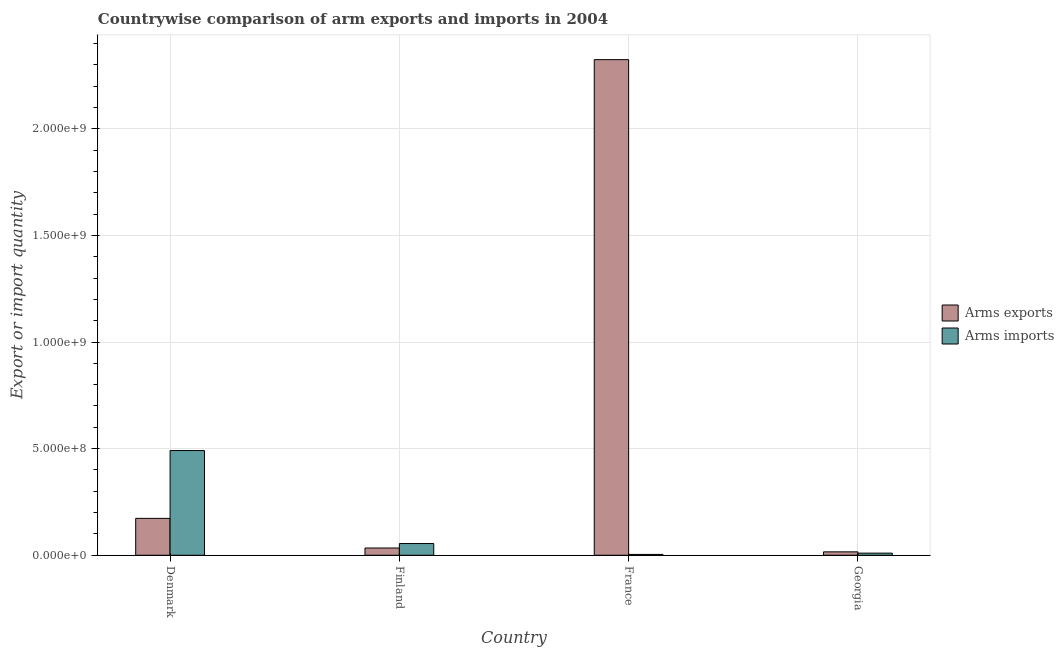Are the number of bars per tick equal to the number of legend labels?
Give a very brief answer. Yes. How many bars are there on the 3rd tick from the left?
Provide a succinct answer. 2. How many bars are there on the 3rd tick from the right?
Keep it short and to the point. 2. What is the label of the 2nd group of bars from the left?
Your answer should be compact. Finland. In how many cases, is the number of bars for a given country not equal to the number of legend labels?
Give a very brief answer. 0. What is the arms exports in France?
Give a very brief answer. 2.32e+09. Across all countries, what is the maximum arms imports?
Provide a short and direct response. 4.91e+08. Across all countries, what is the minimum arms imports?
Your answer should be compact. 4.00e+06. In which country was the arms exports minimum?
Offer a very short reply. Georgia. What is the total arms imports in the graph?
Offer a terse response. 5.60e+08. What is the difference between the arms imports in Finland and that in Georgia?
Offer a terse response. 4.50e+07. What is the difference between the arms exports in Denmark and the arms imports in Finland?
Give a very brief answer. 1.18e+08. What is the average arms exports per country?
Offer a terse response. 6.37e+08. What is the difference between the arms exports and arms imports in Finland?
Provide a succinct answer. -2.10e+07. What is the ratio of the arms exports in Denmark to that in Georgia?
Keep it short and to the point. 10.81. Is the arms exports in Finland less than that in France?
Ensure brevity in your answer.  Yes. Is the difference between the arms exports in Denmark and Finland greater than the difference between the arms imports in Denmark and Finland?
Your answer should be very brief. No. What is the difference between the highest and the second highest arms exports?
Give a very brief answer. 2.15e+09. What is the difference between the highest and the lowest arms imports?
Your answer should be compact. 4.87e+08. What does the 1st bar from the left in Georgia represents?
Offer a terse response. Arms exports. What does the 2nd bar from the right in France represents?
Give a very brief answer. Arms exports. How many bars are there?
Provide a short and direct response. 8. Are all the bars in the graph horizontal?
Your answer should be compact. No. How many countries are there in the graph?
Keep it short and to the point. 4. What is the difference between two consecutive major ticks on the Y-axis?
Keep it short and to the point. 5.00e+08. Are the values on the major ticks of Y-axis written in scientific E-notation?
Offer a very short reply. Yes. Does the graph contain any zero values?
Your response must be concise. No. How are the legend labels stacked?
Offer a very short reply. Vertical. What is the title of the graph?
Offer a very short reply. Countrywise comparison of arm exports and imports in 2004. Does "State government" appear as one of the legend labels in the graph?
Keep it short and to the point. No. What is the label or title of the Y-axis?
Ensure brevity in your answer.  Export or import quantity. What is the Export or import quantity in Arms exports in Denmark?
Give a very brief answer. 1.73e+08. What is the Export or import quantity of Arms imports in Denmark?
Offer a very short reply. 4.91e+08. What is the Export or import quantity in Arms exports in Finland?
Your answer should be compact. 3.40e+07. What is the Export or import quantity in Arms imports in Finland?
Give a very brief answer. 5.50e+07. What is the Export or import quantity of Arms exports in France?
Your answer should be compact. 2.32e+09. What is the Export or import quantity of Arms imports in France?
Provide a short and direct response. 4.00e+06. What is the Export or import quantity of Arms exports in Georgia?
Your answer should be very brief. 1.60e+07. What is the Export or import quantity of Arms imports in Georgia?
Make the answer very short. 1.00e+07. Across all countries, what is the maximum Export or import quantity of Arms exports?
Offer a very short reply. 2.32e+09. Across all countries, what is the maximum Export or import quantity of Arms imports?
Offer a terse response. 4.91e+08. Across all countries, what is the minimum Export or import quantity in Arms exports?
Provide a succinct answer. 1.60e+07. What is the total Export or import quantity in Arms exports in the graph?
Your answer should be very brief. 2.55e+09. What is the total Export or import quantity of Arms imports in the graph?
Offer a terse response. 5.60e+08. What is the difference between the Export or import quantity of Arms exports in Denmark and that in Finland?
Make the answer very short. 1.39e+08. What is the difference between the Export or import quantity in Arms imports in Denmark and that in Finland?
Ensure brevity in your answer.  4.36e+08. What is the difference between the Export or import quantity in Arms exports in Denmark and that in France?
Ensure brevity in your answer.  -2.15e+09. What is the difference between the Export or import quantity of Arms imports in Denmark and that in France?
Provide a short and direct response. 4.87e+08. What is the difference between the Export or import quantity of Arms exports in Denmark and that in Georgia?
Your answer should be very brief. 1.57e+08. What is the difference between the Export or import quantity of Arms imports in Denmark and that in Georgia?
Your answer should be compact. 4.81e+08. What is the difference between the Export or import quantity in Arms exports in Finland and that in France?
Give a very brief answer. -2.29e+09. What is the difference between the Export or import quantity of Arms imports in Finland and that in France?
Offer a very short reply. 5.10e+07. What is the difference between the Export or import quantity of Arms exports in Finland and that in Georgia?
Your answer should be compact. 1.80e+07. What is the difference between the Export or import quantity of Arms imports in Finland and that in Georgia?
Provide a succinct answer. 4.50e+07. What is the difference between the Export or import quantity of Arms exports in France and that in Georgia?
Provide a succinct answer. 2.31e+09. What is the difference between the Export or import quantity of Arms imports in France and that in Georgia?
Your answer should be compact. -6.00e+06. What is the difference between the Export or import quantity of Arms exports in Denmark and the Export or import quantity of Arms imports in Finland?
Your response must be concise. 1.18e+08. What is the difference between the Export or import quantity of Arms exports in Denmark and the Export or import quantity of Arms imports in France?
Keep it short and to the point. 1.69e+08. What is the difference between the Export or import quantity in Arms exports in Denmark and the Export or import quantity in Arms imports in Georgia?
Your response must be concise. 1.63e+08. What is the difference between the Export or import quantity of Arms exports in Finland and the Export or import quantity of Arms imports in France?
Provide a succinct answer. 3.00e+07. What is the difference between the Export or import quantity of Arms exports in Finland and the Export or import quantity of Arms imports in Georgia?
Provide a short and direct response. 2.40e+07. What is the difference between the Export or import quantity in Arms exports in France and the Export or import quantity in Arms imports in Georgia?
Offer a terse response. 2.31e+09. What is the average Export or import quantity of Arms exports per country?
Offer a terse response. 6.37e+08. What is the average Export or import quantity in Arms imports per country?
Give a very brief answer. 1.40e+08. What is the difference between the Export or import quantity in Arms exports and Export or import quantity in Arms imports in Denmark?
Keep it short and to the point. -3.18e+08. What is the difference between the Export or import quantity of Arms exports and Export or import quantity of Arms imports in Finland?
Your answer should be very brief. -2.10e+07. What is the difference between the Export or import quantity of Arms exports and Export or import quantity of Arms imports in France?
Your answer should be very brief. 2.32e+09. What is the ratio of the Export or import quantity of Arms exports in Denmark to that in Finland?
Your answer should be compact. 5.09. What is the ratio of the Export or import quantity in Arms imports in Denmark to that in Finland?
Offer a terse response. 8.93. What is the ratio of the Export or import quantity of Arms exports in Denmark to that in France?
Offer a terse response. 0.07. What is the ratio of the Export or import quantity in Arms imports in Denmark to that in France?
Your answer should be compact. 122.75. What is the ratio of the Export or import quantity in Arms exports in Denmark to that in Georgia?
Offer a very short reply. 10.81. What is the ratio of the Export or import quantity in Arms imports in Denmark to that in Georgia?
Ensure brevity in your answer.  49.1. What is the ratio of the Export or import quantity of Arms exports in Finland to that in France?
Offer a terse response. 0.01. What is the ratio of the Export or import quantity of Arms imports in Finland to that in France?
Provide a succinct answer. 13.75. What is the ratio of the Export or import quantity of Arms exports in Finland to that in Georgia?
Provide a succinct answer. 2.12. What is the ratio of the Export or import quantity of Arms imports in Finland to that in Georgia?
Your response must be concise. 5.5. What is the ratio of the Export or import quantity in Arms exports in France to that in Georgia?
Give a very brief answer. 145.25. What is the ratio of the Export or import quantity in Arms imports in France to that in Georgia?
Keep it short and to the point. 0.4. What is the difference between the highest and the second highest Export or import quantity in Arms exports?
Your response must be concise. 2.15e+09. What is the difference between the highest and the second highest Export or import quantity in Arms imports?
Your answer should be very brief. 4.36e+08. What is the difference between the highest and the lowest Export or import quantity in Arms exports?
Make the answer very short. 2.31e+09. What is the difference between the highest and the lowest Export or import quantity in Arms imports?
Keep it short and to the point. 4.87e+08. 